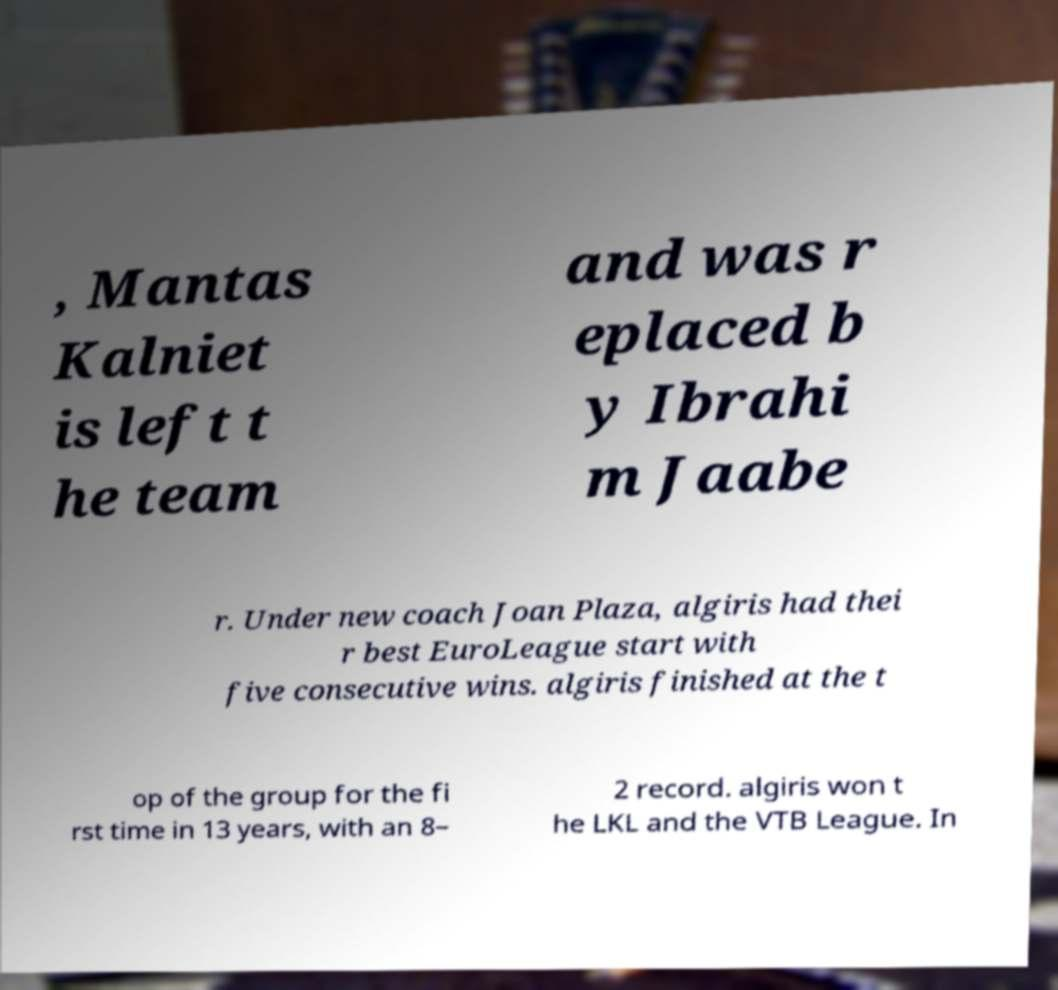Could you assist in decoding the text presented in this image and type it out clearly? , Mantas Kalniet is left t he team and was r eplaced b y Ibrahi m Jaabe r. Under new coach Joan Plaza, algiris had thei r best EuroLeague start with five consecutive wins. algiris finished at the t op of the group for the fi rst time in 13 years, with an 8– 2 record. algiris won t he LKL and the VTB League. In 